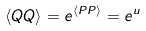Convert formula to latex. <formula><loc_0><loc_0><loc_500><loc_500>\langle Q Q \rangle = e ^ { \langle P P \rangle } = e ^ { u }</formula> 